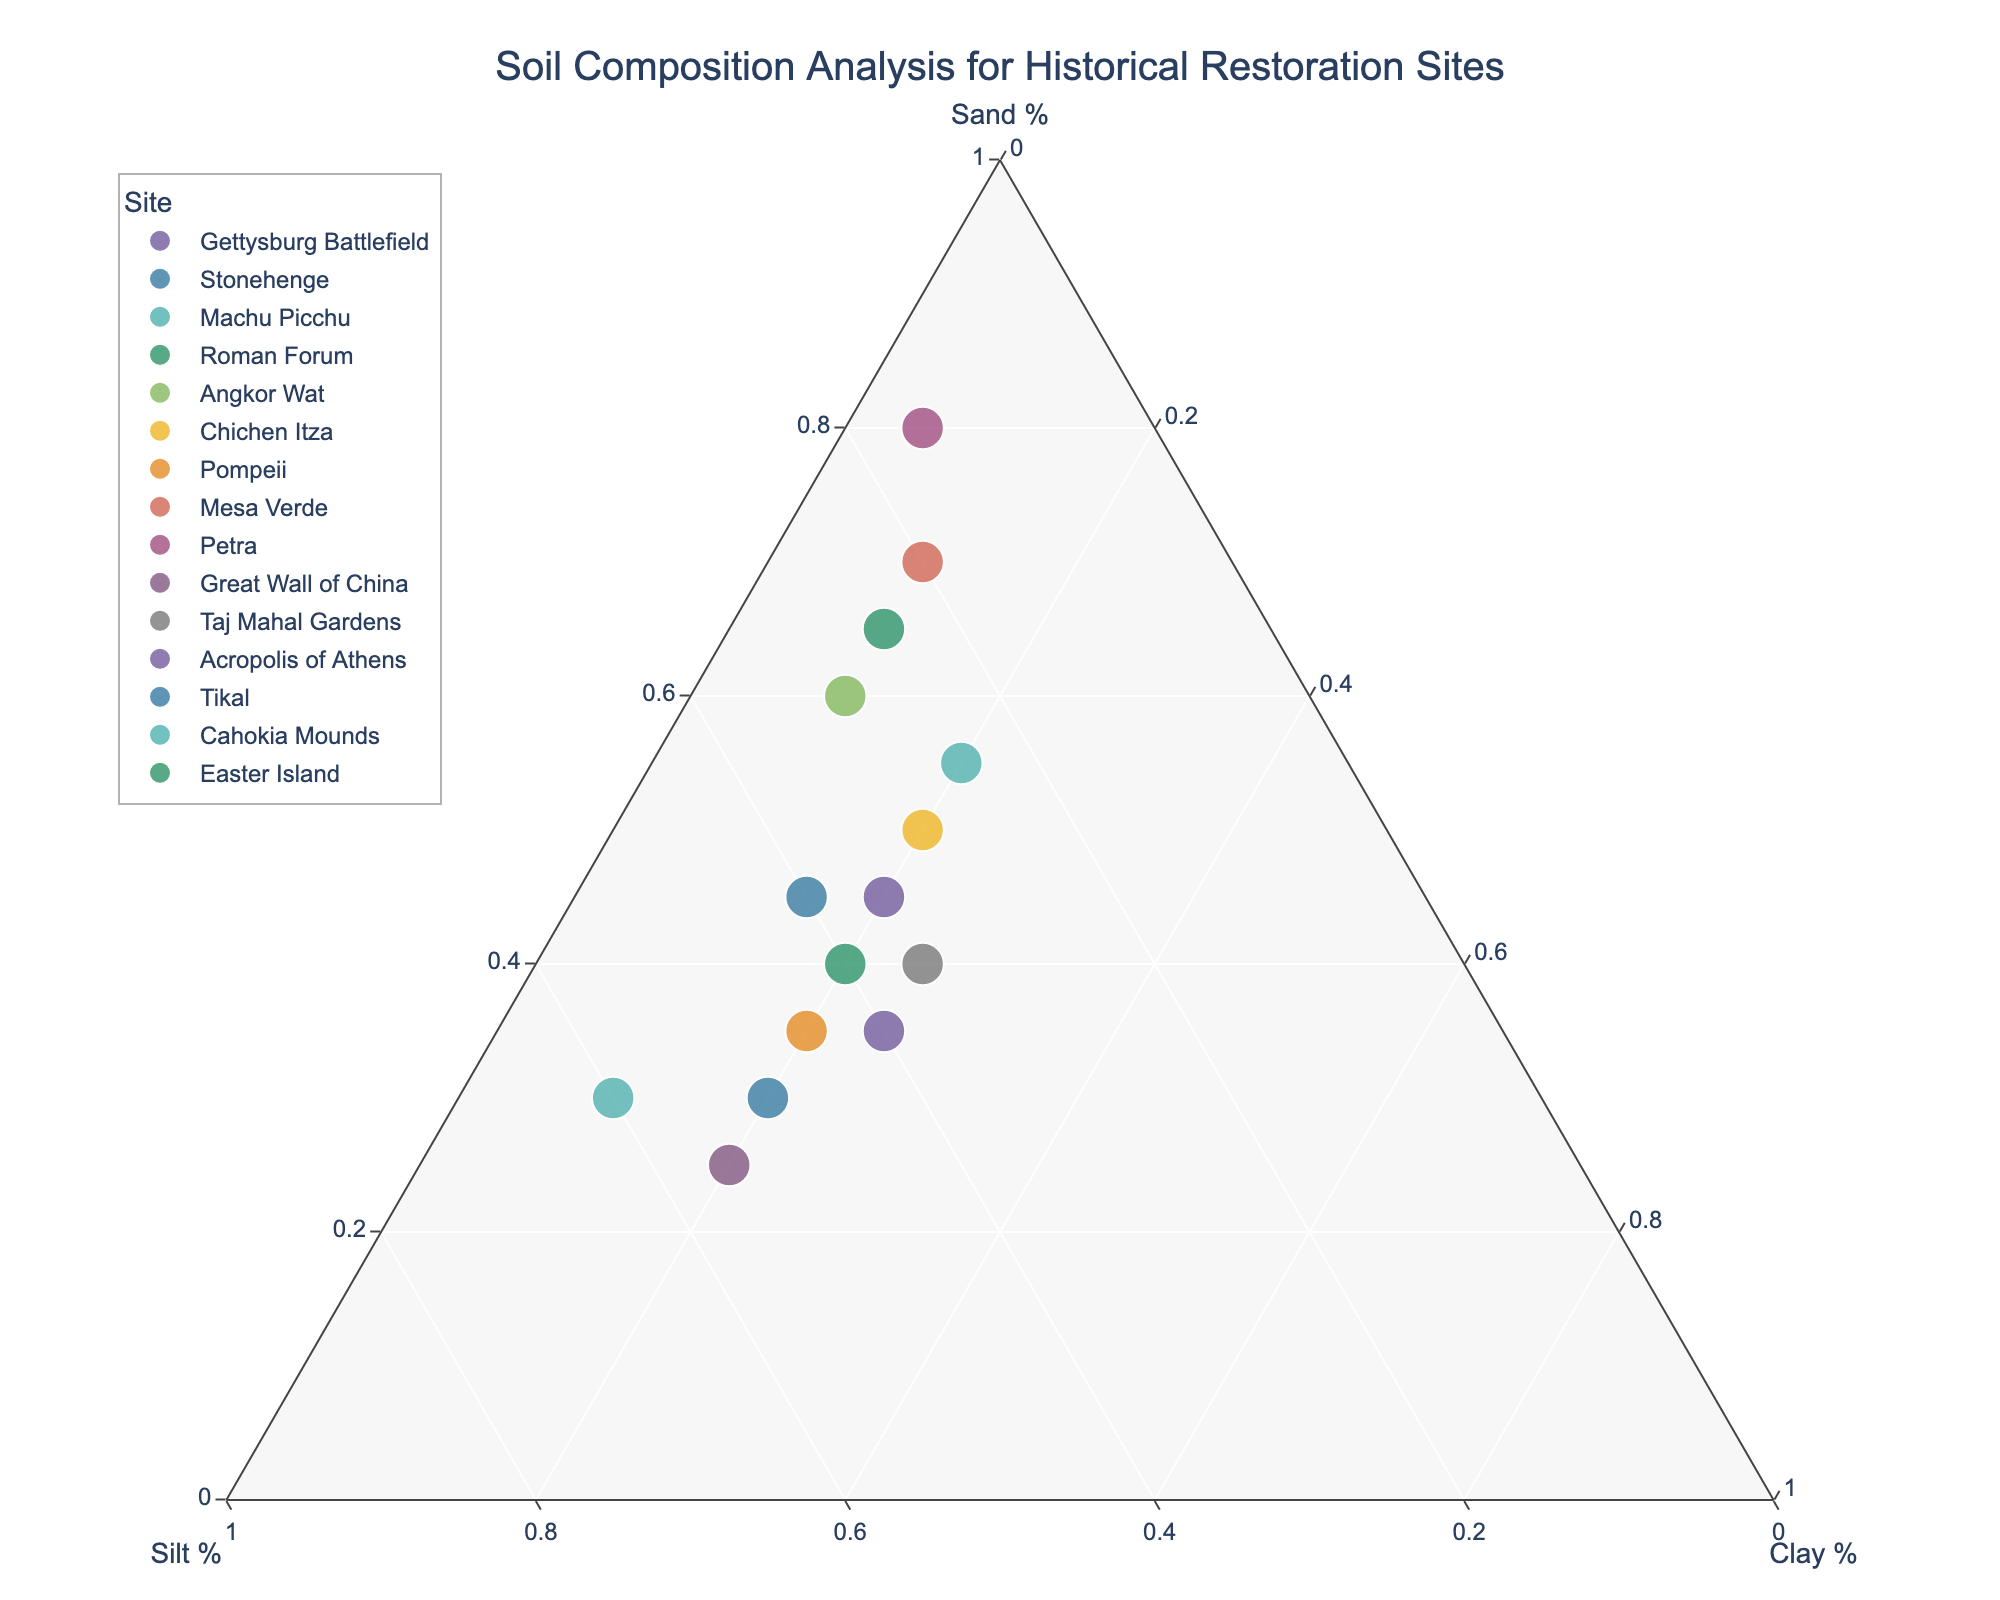What historical restoration site has the highest percentage of sand? By referring to the figure, the site with the highest percentage of sand will be the data point closest to the "Sand" vertex on the ternary plot.
Answer: Petra What's the total number of historical restoration sites analyzed in the plot? Count the number of distinct data points representing different sites in the ternary plot.
Answer: 15 Which site has an equal percentage of sand and silt? Look for the data points where the values of sand and silt are the same on the ternary plot, and check the hover information for confirmation.
Answer: Roman Forum Which historical restoration site has the most balanced soil composition? The most balanced soil composition would likely be the data point nearest to the center of the ternary plot, where sand, silt, and clay percentages are most even.
Answer: Great Wall of China What's the difference in the percentage of clay between Taj Mahal Gardens and Acropolis of Athens? Compare the percentages of clay for these two sites by checking their positions on the clay axis. Subtract the smaller value from the larger one.
Answer: 0% Which historical restoration site has the highest percentage of silt? Identify the data point closest to the "Silt" vertex on the ternary plot.
Answer: Cahokia Mounds Which historical restoration site has the lowest percentage of clay? Find the data point closest to the baseline opposite the "Clay" vertex to identify the site with the lowest percentage of clay.
Answer: Petra Are there more sites with clay percentages above 20% or below? Count the number of data points on each side of the 20% clay line in the ternary plot.
Answer: Below 20% What's the average sand percentage across all historical restoration sites? Sum the sand percentages of all sites and divide by the total number of sites (15).
Answer: 47% Which historical restoration sites have the exact percentage of clay? Look for the data points that have exactly the same values on the clay axis and identify the sites these points represent.
Answer: Gettysburg Battlefield, Angkor Wat, Stonehenge, Machu Picchu, Easter Island, Cahokia Mounds, etc 